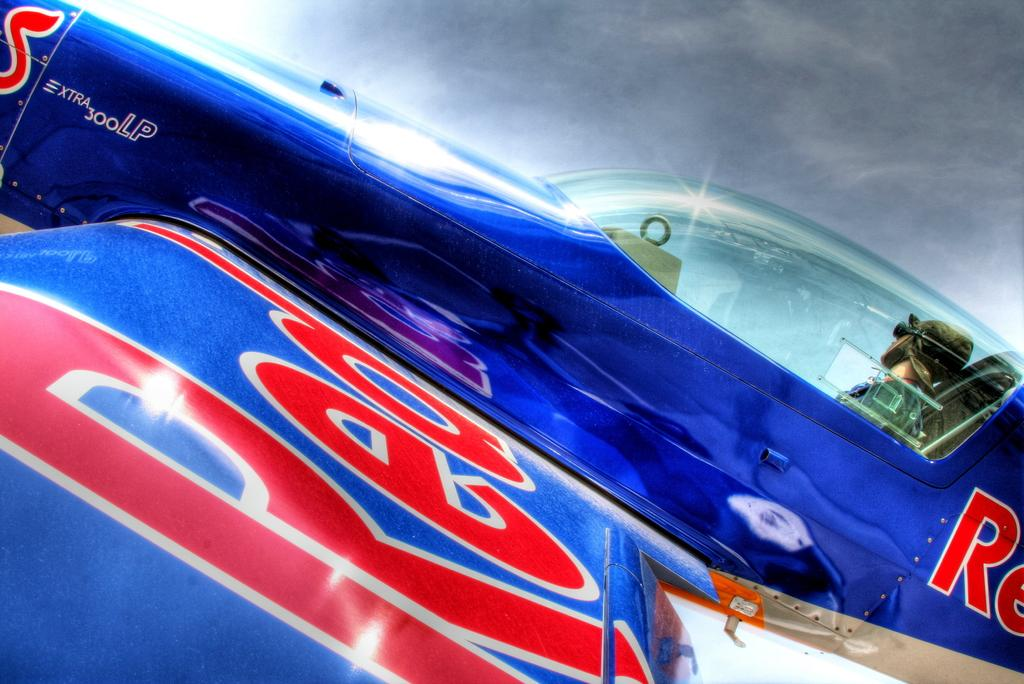Provide a one-sentence caption for the provided image. A pilot is in the cockpit of a blue plane that has the word "red" on the wing. 